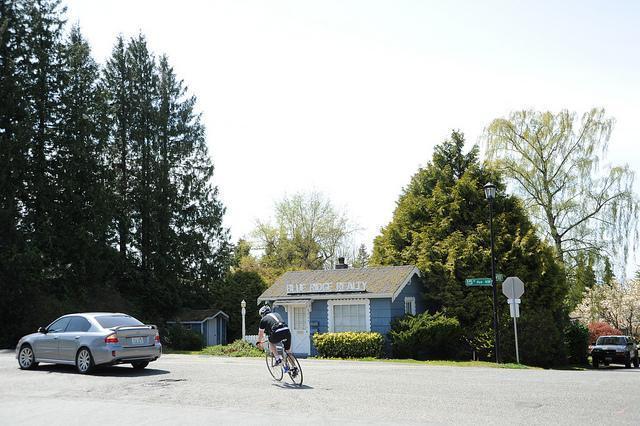How many elephants are there?
Give a very brief answer. 0. 